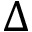<formula> <loc_0><loc_0><loc_500><loc_500>\Delta</formula> 